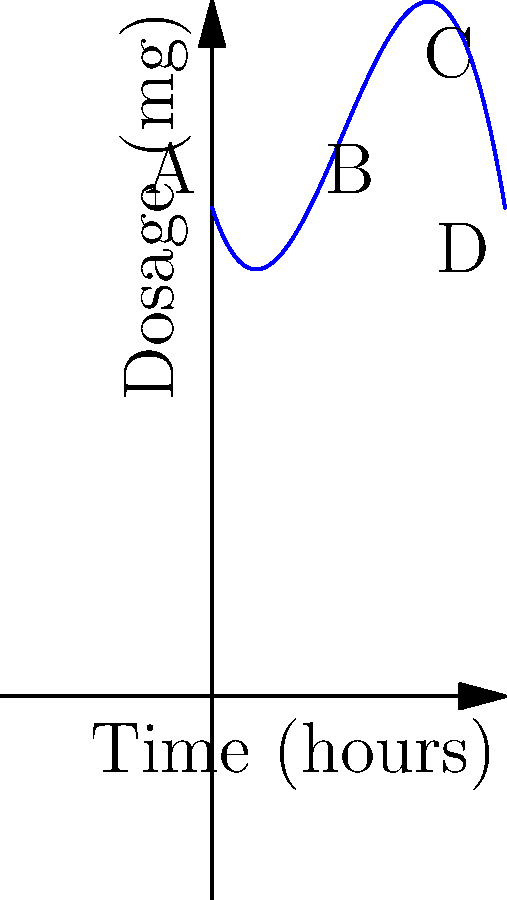The graph represents the concentration of a medication in a patient's bloodstream over time. The function is given by $f(x) = -0.25x^3 + 2x^2 - 3x + 10$, where $x$ is time in hours and $f(x)$ is the dosage in milligrams. At which point does the medication reach its peak concentration? To find the peak concentration, we need to determine the maximum point of the function. Let's approach this step-by-step:

1) The maximum point occurs where the derivative of the function equals zero. Let's find the derivative:
   $f'(x) = -0.75x^2 + 4x - 3$

2) Set the derivative to zero and solve:
   $-0.75x^2 + 4x - 3 = 0$

3) This is a quadratic equation. We can solve it using the quadratic formula:
   $x = \frac{-b \pm \sqrt{b^2 - 4ac}}{2a}$

   Where $a = -0.75$, $b = 4$, and $c = -3$

4) Plugging in these values:
   $x = \frac{-4 \pm \sqrt{16 - 4(-0.75)(-3)}}{2(-0.75)}$
   $= \frac{-4 \pm \sqrt{16 - 9}}{-1.5}$
   $= \frac{-4 \pm \sqrt{7}}{-1.5}$

5) This gives us two solutions:
   $x_1 \approx 0.82$ and $x_2 \approx 4.51$

6) The second solution, $x_2 \approx 4.51$, corresponds to the maximum point as it's the larger value.

7) Looking at the graph, we can see that point C is closest to $x = 4.51$ hours.

Therefore, the medication reaches its peak concentration at point C, approximately 4.51 hours after administration.
Answer: Point C 